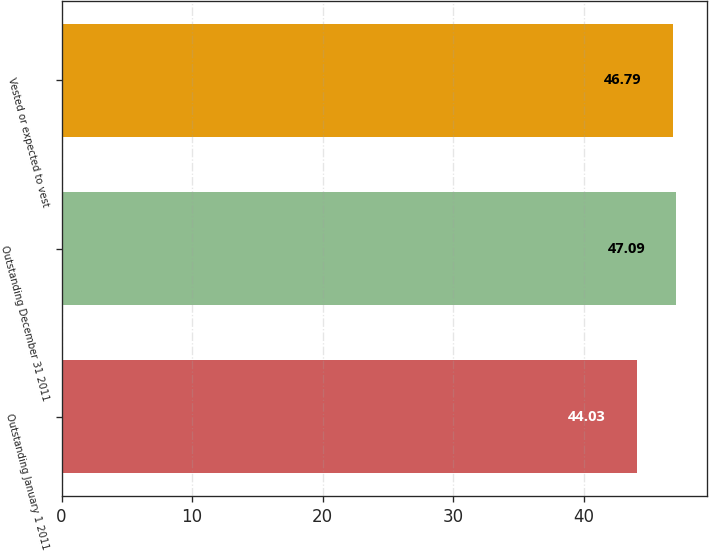Convert chart. <chart><loc_0><loc_0><loc_500><loc_500><bar_chart><fcel>Outstanding January 1 2011<fcel>Outstanding December 31 2011<fcel>Vested or expected to vest<nl><fcel>44.03<fcel>47.09<fcel>46.79<nl></chart> 